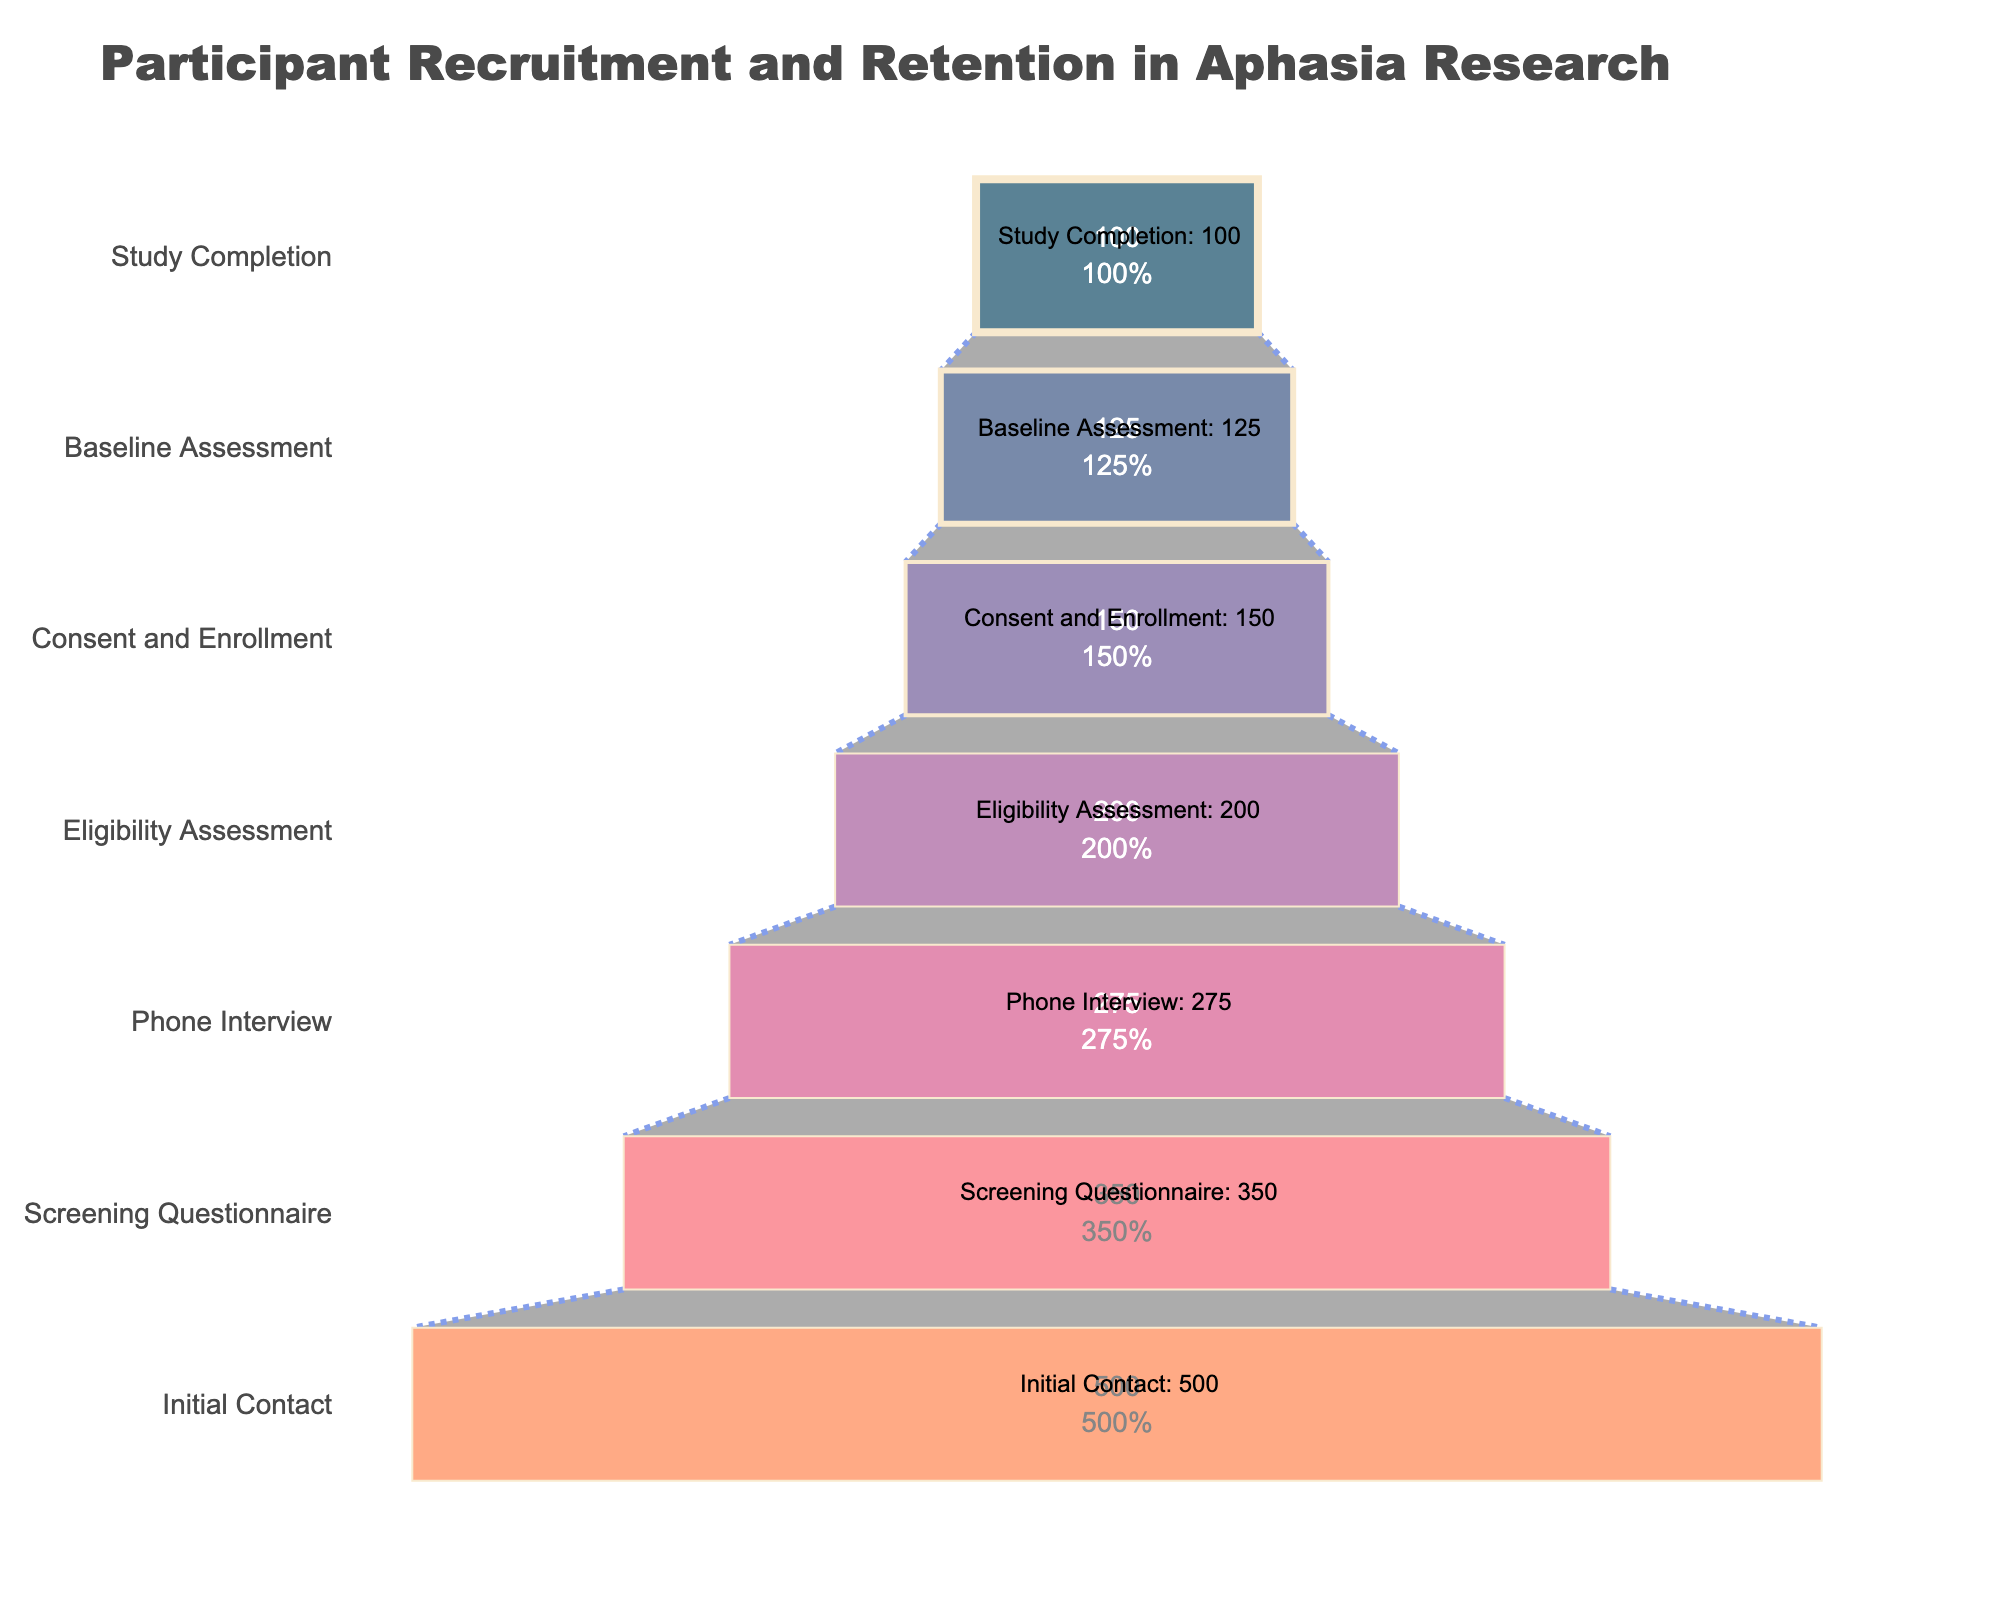Which stage has the highest number of participants? The stage with the highest number of participants is at the top of the funnel chart. It is the "Initial Contact" stage.
Answer: Initial Contact Which stage has the lowest number of participants? The stage with the lowest number of participants is at the bottom of the funnel chart. It is the "Study Completion" stage.
Answer: Study Completion How many participants were lost between the 'Screening Questionnaire' and 'Phone Interview' stages? Subtract the number of participants in the 'Phone Interview' stage from those in the 'Screening Questionnaire' stage: 350 - 275.
Answer: 75 What percentage of participants make it from 'Eligibility Assessment' to 'Study Completion'? Starting with 200 participants at 'Eligibility Assessment' and 100 participants at 'Study Completion'. The percentage is (100/200) * 100%.
Answer: 50% What is the participant reduction percentage from 'Initial Contact' to 'Study Completion'? Starting with 500 participants at 'Initial Contact' and ending with 100 participants at 'Study Completion'. The reduction percentage is ((500 - 100) / 500) * 100%.
Answer: 80% What is the attrition rate between 'Consent and Enrollment' and 'Baseline Assessment'? There are 150 participants at 'Consent and Enrollment' and 125 participants at 'Baseline Assessment'. The attrition rate is ((150 - 125) / 150) * 100%.
Answer: 16.67% Compare the number of participants between the 'Phone Interview' and 'Baseline Assessment' stages. Which stage has more participants? The 'Phone Interview' stage has 275 participants, while the 'Baseline Assessment' stage has 125 participants. 275 is greater than 125.
Answer: Phone Interview By how much do participant numbers drop from 'Screening Questionnaire' to 'Baseline Assessment'? From 'Screening Questionnaire' (350) to 'Baseline Assessment' (125), the drop in participant numbers is 350 - 125.
Answer: 225 What's the average number of participants across all stages? Sum the number of participants at all stages and divide by the number of stages. (500 + 350 + 275 + 200 + 150 + 125 + 100) / 7.
Answer: 242.86 What is the participant retention rate from 'Baseline Assessment' to 'Study Completion'? With 125 participants at 'Baseline Assessment' and 100 at 'Study Completion', the retention rate is (100 / 125) * 100%.
Answer: 80% 